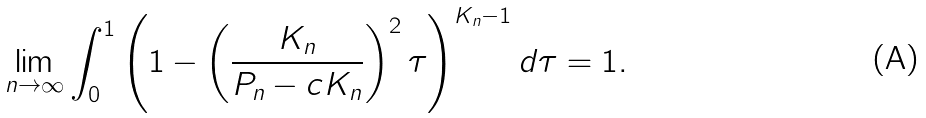Convert formula to latex. <formula><loc_0><loc_0><loc_500><loc_500>\lim _ { n \rightarrow \infty } \int _ { 0 } ^ { 1 } \left ( 1 - \left ( \frac { K _ { n } } { P _ { n } - c K _ { n } } \right ) ^ { 2 } \tau \right ) ^ { K _ { n } - 1 } d \tau = 1 .</formula> 